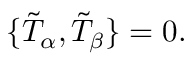Convert formula to latex. <formula><loc_0><loc_0><loc_500><loc_500>\{ \tilde { T } _ { \alpha } , \tilde { T } _ { \beta } \} = 0 .</formula> 